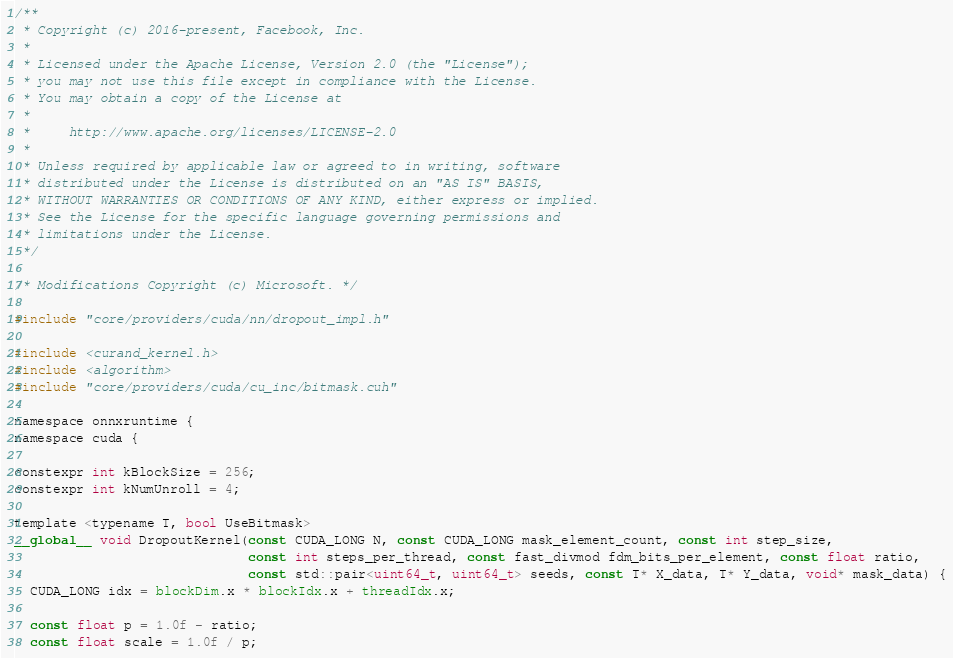<code> <loc_0><loc_0><loc_500><loc_500><_Cuda_>/**
 * Copyright (c) 2016-present, Facebook, Inc.
 *
 * Licensed under the Apache License, Version 2.0 (the "License");
 * you may not use this file except in compliance with the License.
 * You may obtain a copy of the License at
 *
 *     http://www.apache.org/licenses/LICENSE-2.0
 *
 * Unless required by applicable law or agreed to in writing, software
 * distributed under the License is distributed on an "AS IS" BASIS,
 * WITHOUT WARRANTIES OR CONDITIONS OF ANY KIND, either express or implied.
 * See the License for the specific language governing permissions and
 * limitations under the License.
 */

/* Modifications Copyright (c) Microsoft. */

#include "core/providers/cuda/nn/dropout_impl.h"

#include <curand_kernel.h>
#include <algorithm>
#include "core/providers/cuda/cu_inc/bitmask.cuh"

namespace onnxruntime {
namespace cuda {

constexpr int kBlockSize = 256;
constexpr int kNumUnroll = 4;

template <typename T, bool UseBitmask>
__global__ void DropoutKernel(const CUDA_LONG N, const CUDA_LONG mask_element_count, const int step_size,
                              const int steps_per_thread, const fast_divmod fdm_bits_per_element, const float ratio,
                              const std::pair<uint64_t, uint64_t> seeds, const T* X_data, T* Y_data, void* mask_data) {
  CUDA_LONG idx = blockDim.x * blockIdx.x + threadIdx.x;

  const float p = 1.0f - ratio;
  const float scale = 1.0f / p;</code> 